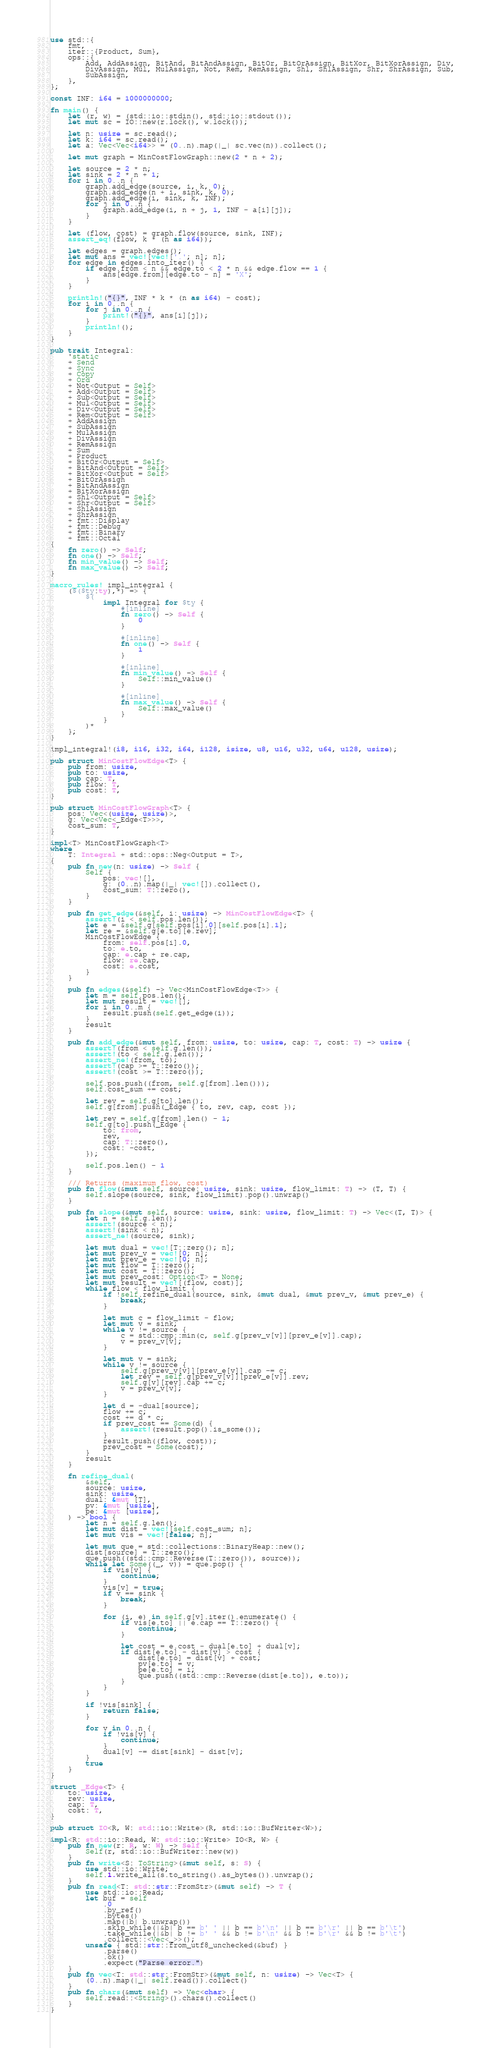<code> <loc_0><loc_0><loc_500><loc_500><_Rust_>use std::{
    fmt,
    iter::{Product, Sum},
    ops::{
        Add, AddAssign, BitAnd, BitAndAssign, BitOr, BitOrAssign, BitXor, BitXorAssign, Div,
        DivAssign, Mul, MulAssign, Not, Rem, RemAssign, Shl, ShlAssign, Shr, ShrAssign, Sub,
        SubAssign,
    },
};

const INF: i64 = 1000000000;

fn main() {
    let (r, w) = (std::io::stdin(), std::io::stdout());
    let mut sc = IO::new(r.lock(), w.lock());

    let n: usize = sc.read();
    let k: i64 = sc.read();
    let a: Vec<Vec<i64>> = (0..n).map(|_| sc.vec(n)).collect();

    let mut graph = MinCostFlowGraph::new(2 * n + 2);

    let source = 2 * n;
    let sink = 2 * n + 1;
    for i in 0..n {
        graph.add_edge(source, i, k, 0);
        graph.add_edge(n + i, sink, k, 0);
        graph.add_edge(i, sink, k, INF);
        for j in 0..n {
            graph.add_edge(i, n + j, 1, INF - a[i][j]);
        }
    }

    let (flow, cost) = graph.flow(source, sink, INF);
    assert_eq!(flow, k * (n as i64));

    let edges = graph.edges();
    let mut ans = vec![vec!['.'; n]; n];
    for edge in edges.into_iter() {
        if edge.from < n && edge.to < 2 * n && edge.flow == 1 {
            ans[edge.from][edge.to - n] = 'X';
        }
    }

    println!("{}", INF * k * (n as i64) - cost);
    for i in 0..n {
        for j in 0..n {
            print!("{}", ans[i][j]);
        }
        println!();
    }
}

pub trait Integral:
    'static
    + Send
    + Sync
    + Copy
    + Ord
    + Not<Output = Self>
    + Add<Output = Self>
    + Sub<Output = Self>
    + Mul<Output = Self>
    + Div<Output = Self>
    + Rem<Output = Self>
    + AddAssign
    + SubAssign
    + MulAssign
    + DivAssign
    + RemAssign
    + Sum
    + Product
    + BitOr<Output = Self>
    + BitAnd<Output = Self>
    + BitXor<Output = Self>
    + BitOrAssign
    + BitAndAssign
    + BitXorAssign
    + Shl<Output = Self>
    + Shr<Output = Self>
    + ShlAssign
    + ShrAssign
    + fmt::Display
    + fmt::Debug
    + fmt::Binary
    + fmt::Octal
{
    fn zero() -> Self;
    fn one() -> Self;
    fn min_value() -> Self;
    fn max_value() -> Self;
}

macro_rules! impl_integral {
    ($($ty:ty),*) => {
        $(
            impl Integral for $ty {
                #[inline]
                fn zero() -> Self {
                    0
                }

                #[inline]
                fn one() -> Self {
                    1
                }

                #[inline]
                fn min_value() -> Self {
                    Self::min_value()
                }

                #[inline]
                fn max_value() -> Self {
                    Self::max_value()
                }
            }
        )*
    };
}

impl_integral!(i8, i16, i32, i64, i128, isize, u8, u16, u32, u64, u128, usize);

pub struct MinCostFlowEdge<T> {
    pub from: usize,
    pub to: usize,
    pub cap: T,
    pub flow: T,
    pub cost: T,
}

pub struct MinCostFlowGraph<T> {
    pos: Vec<(usize, usize)>,
    g: Vec<Vec<_Edge<T>>>,
    cost_sum: T,
}

impl<T> MinCostFlowGraph<T>
where
    T: Integral + std::ops::Neg<Output = T>,
{
    pub fn new(n: usize) -> Self {
        Self {
            pos: vec![],
            g: (0..n).map(|_| vec![]).collect(),
            cost_sum: T::zero(),
        }
    }

    pub fn get_edge(&self, i: usize) -> MinCostFlowEdge<T> {
        assert!(i < self.pos.len());
        let e = &self.g[self.pos[i].0][self.pos[i].1];
        let re = &self.g[e.to][e.rev];
        MinCostFlowEdge {
            from: self.pos[i].0,
            to: e.to,
            cap: e.cap + re.cap,
            flow: re.cap,
            cost: e.cost,
        }
    }

    pub fn edges(&self) -> Vec<MinCostFlowEdge<T>> {
        let m = self.pos.len();
        let mut result = vec![];
        for i in 0..m {
            result.push(self.get_edge(i));
        }
        result
    }

    pub fn add_edge(&mut self, from: usize, to: usize, cap: T, cost: T) -> usize {
        assert!(from < self.g.len());
        assert!(to < self.g.len());
        assert_ne!(from, to);
        assert!(cap >= T::zero());
        assert!(cost >= T::zero());

        self.pos.push((from, self.g[from].len()));
        self.cost_sum += cost;

        let rev = self.g[to].len();
        self.g[from].push(_Edge { to, rev, cap, cost });

        let rev = self.g[from].len() - 1;
        self.g[to].push(_Edge {
            to: from,
            rev,
            cap: T::zero(),
            cost: -cost,
        });

        self.pos.len() - 1
    }

    /// Returns (maximum flow, cost)
    pub fn flow(&mut self, source: usize, sink: usize, flow_limit: T) -> (T, T) {
        self.slope(source, sink, flow_limit).pop().unwrap()
    }

    pub fn slope(&mut self, source: usize, sink: usize, flow_limit: T) -> Vec<(T, T)> {
        let n = self.g.len();
        assert!(source < n);
        assert!(sink < n);
        assert_ne!(source, sink);

        let mut dual = vec![T::zero(); n];
        let mut prev_v = vec![0; n];
        let mut prev_e = vec![0; n];
        let mut flow = T::zero();
        let mut cost = T::zero();
        let mut prev_cost: Option<T> = None;
        let mut result = vec![(flow, cost)];
        while flow < flow_limit {
            if !self.refine_dual(source, sink, &mut dual, &mut prev_v, &mut prev_e) {
                break;
            }

            let mut c = flow_limit - flow;
            let mut v = sink;
            while v != source {
                c = std::cmp::min(c, self.g[prev_v[v]][prev_e[v]].cap);
                v = prev_v[v];
            }

            let mut v = sink;
            while v != source {
                self.g[prev_v[v]][prev_e[v]].cap -= c;
                let rev = self.g[prev_v[v]][prev_e[v]].rev;
                self.g[v][rev].cap += c;
                v = prev_v[v];
            }

            let d = -dual[source];
            flow += c;
            cost += d * c;
            if prev_cost == Some(d) {
                assert!(result.pop().is_some());
            }
            result.push((flow, cost));
            prev_cost = Some(cost);
        }
        result
    }

    fn refine_dual(
        &self,
        source: usize,
        sink: usize,
        dual: &mut [T],
        pv: &mut [usize],
        pe: &mut [usize],
    ) -> bool {
        let n = self.g.len();
        let mut dist = vec![self.cost_sum; n];
        let mut vis = vec![false; n];

        let mut que = std::collections::BinaryHeap::new();
        dist[source] = T::zero();
        que.push((std::cmp::Reverse(T::zero()), source));
        while let Some((_, v)) = que.pop() {
            if vis[v] {
                continue;
            }
            vis[v] = true;
            if v == sink {
                break;
            }

            for (i, e) in self.g[v].iter().enumerate() {
                if vis[e.to] || e.cap == T::zero() {
                    continue;
                }

                let cost = e.cost - dual[e.to] + dual[v];
                if dist[e.to] - dist[v] > cost {
                    dist[e.to] = dist[v] + cost;
                    pv[e.to] = v;
                    pe[e.to] = i;
                    que.push((std::cmp::Reverse(dist[e.to]), e.to));
                }
            }
        }

        if !vis[sink] {
            return false;
        }

        for v in 0..n {
            if !vis[v] {
                continue;
            }
            dual[v] -= dist[sink] - dist[v];
        }
        true
    }
}

struct _Edge<T> {
    to: usize,
    rev: usize,
    cap: T,
    cost: T,
}

pub struct IO<R, W: std::io::Write>(R, std::io::BufWriter<W>);

impl<R: std::io::Read, W: std::io::Write> IO<R, W> {
    pub fn new(r: R, w: W) -> Self {
        Self(r, std::io::BufWriter::new(w))
    }
    pub fn write<S: ToString>(&mut self, s: S) {
        use std::io::Write;
        self.1.write_all(s.to_string().as_bytes()).unwrap();
    }
    pub fn read<T: std::str::FromStr>(&mut self) -> T {
        use std::io::Read;
        let buf = self
            .0
            .by_ref()
            .bytes()
            .map(|b| b.unwrap())
            .skip_while(|&b| b == b' ' || b == b'\n' || b == b'\r' || b == b'\t')
            .take_while(|&b| b != b' ' && b != b'\n' && b != b'\r' && b != b'\t')
            .collect::<Vec<_>>();
        unsafe { std::str::from_utf8_unchecked(&buf) }
            .parse()
            .ok()
            .expect("Parse error.")
    }
    pub fn vec<T: std::str::FromStr>(&mut self, n: usize) -> Vec<T> {
        (0..n).map(|_| self.read()).collect()
    }
    pub fn chars(&mut self) -> Vec<char> {
        self.read::<String>().chars().collect()
    }
}
</code> 